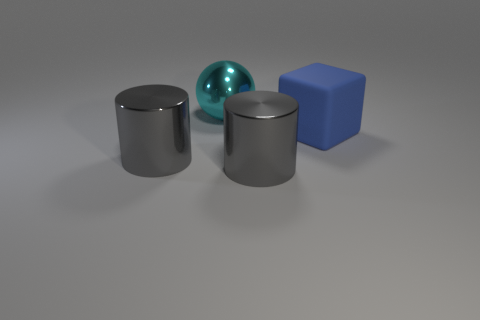Subtract 1 cubes. How many cubes are left? 0 Add 1 large blue matte cylinders. How many objects exist? 5 Subtract all balls. How many objects are left? 3 Subtract 1 cyan spheres. How many objects are left? 3 Subtract all brown spheres. Subtract all red cylinders. How many spheres are left? 1 Subtract all big cyan metallic things. Subtract all spheres. How many objects are left? 2 Add 3 large blue rubber objects. How many large blue rubber objects are left? 4 Add 4 big cyan objects. How many big cyan objects exist? 5 